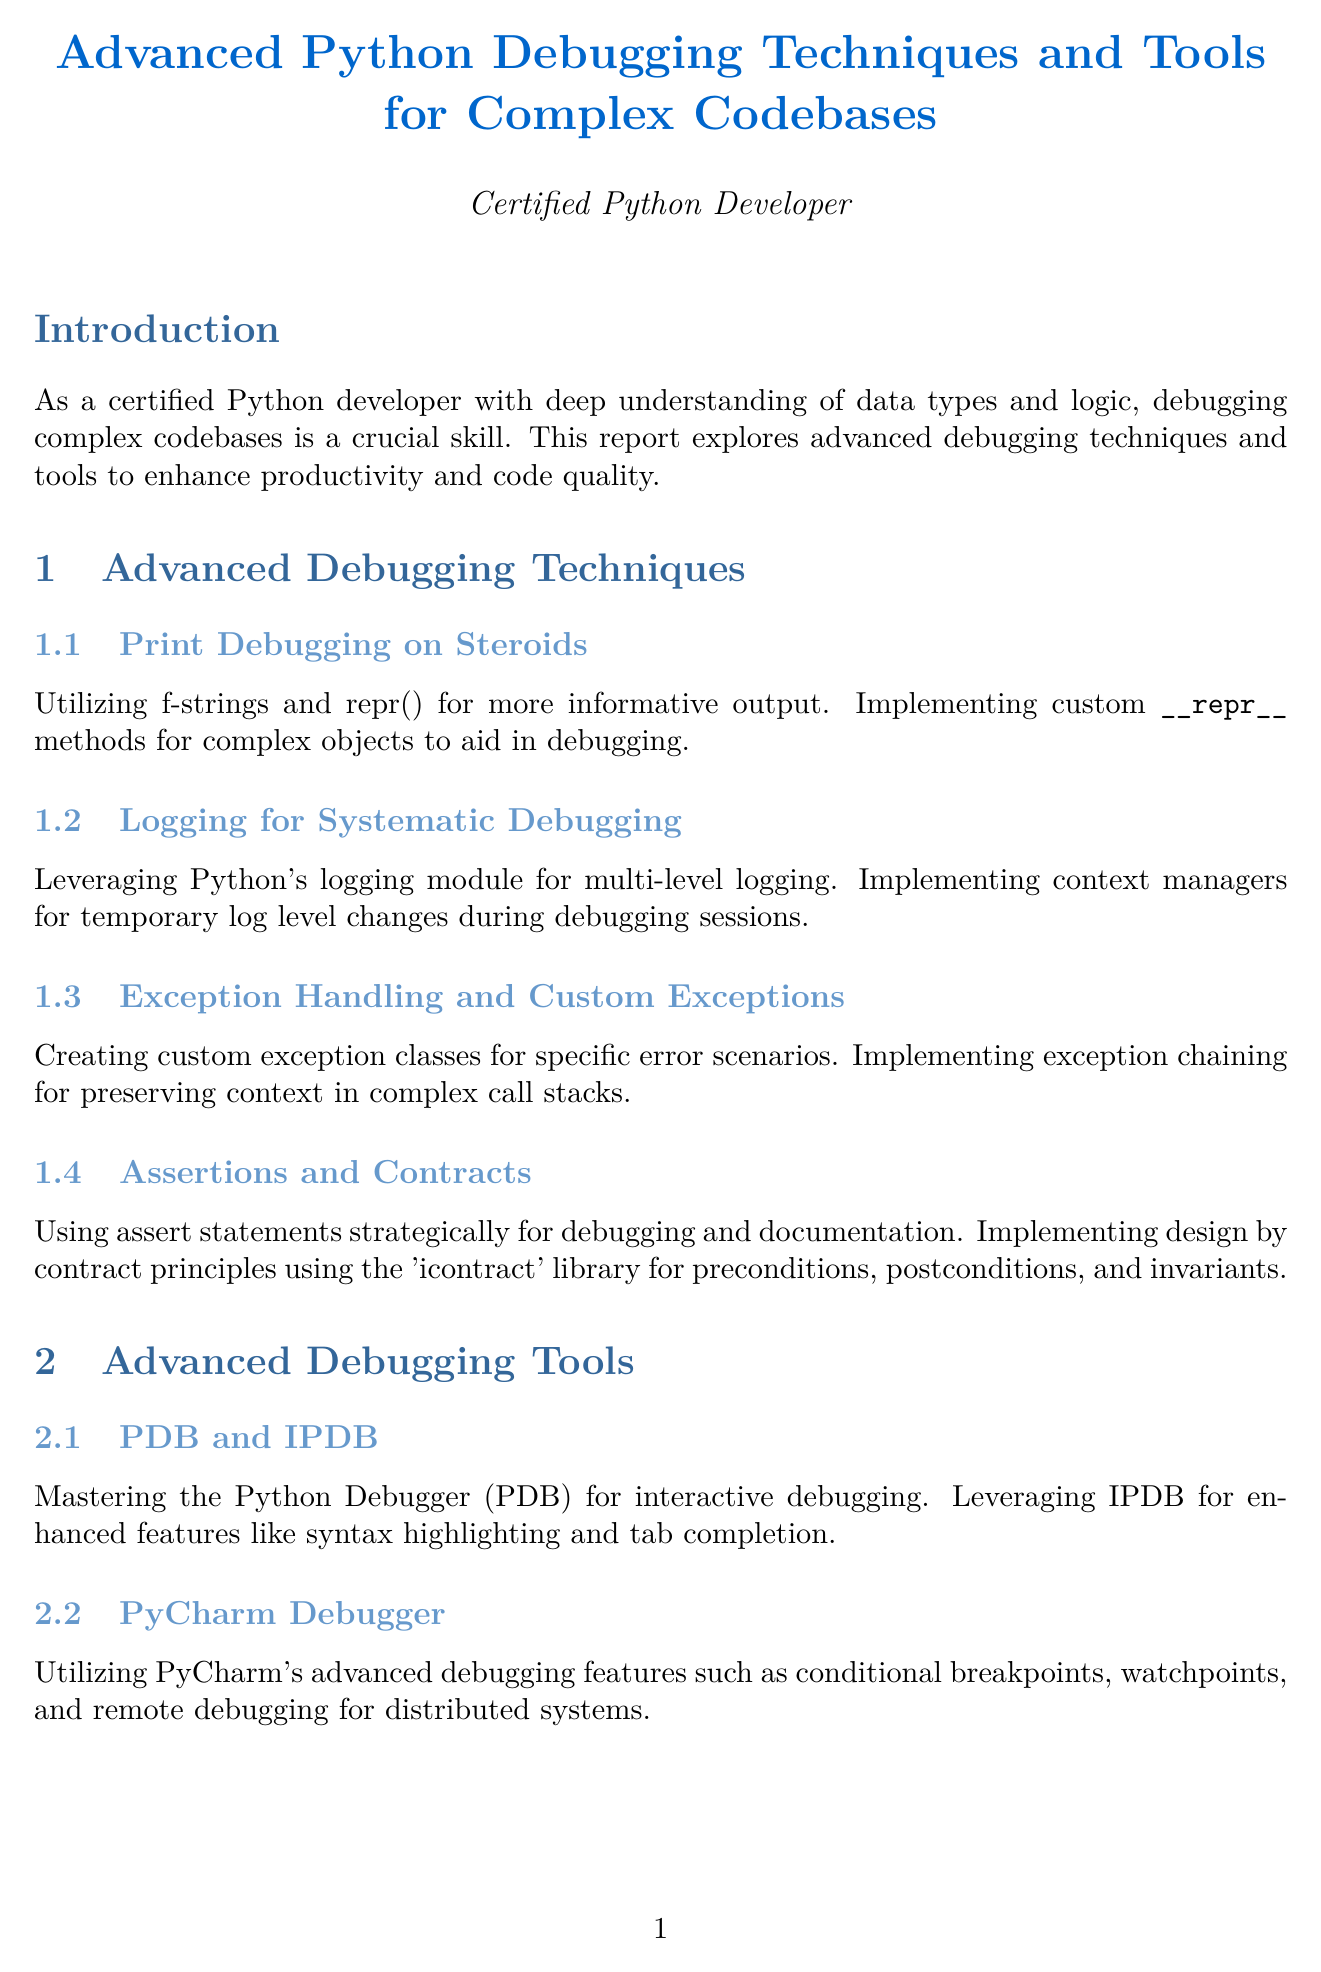What is the title of the report? The title of the report is stated in the first section, which introduces the main topic.
Answer: Advanced Python Debugging Techniques and Tools for Complex Codebases How many subsections are there under "Advanced Debugging Techniques"? The number of subsections is listed in the section details for "Advanced Debugging Techniques."
Answer: Four What tool is mentioned for interactive debugging? The document identifies specific tools under "Advanced Debugging Tools," including the relevant tools for debugging.
Answer: PDB Which library is used for implementing design by contract principles? The specific library mentioned for this purpose is provided in the section discussing assertions and contracts.
Answer: icontract What debugging technique is suggested for asynchronous code? This technique is highlighted in a subsection focused on asynchronous programming within the document.
Answer: aiodebugger How does the report suggest handling memory leaks in Django applications? The case study describes a step-by-step process that utilizes specific tools for identifying issues in Django applications.
Answer: memory_profiler and objgraph What is the purpose of using git bisect? The content in the document explains the use of this tool in relation to bug hunting in codebases.
Answer: To efficiently locate commits that introduced bugs What is emphasized as crucial for Python developers at the end of the report? The conclusion summarizes the overall message about the importance of mastering specific techniques and tools for developer capabilities.
Answer: Continuous learning and practice 